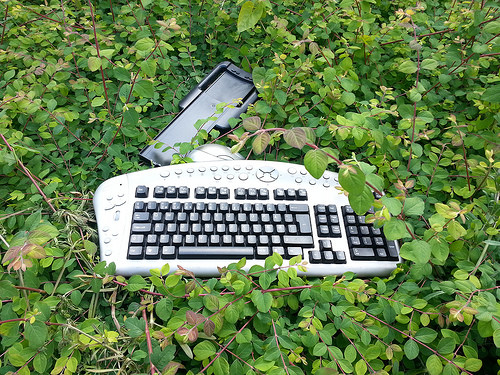<image>
Can you confirm if the keyboard is behind the plants? No. The keyboard is not behind the plants. From this viewpoint, the keyboard appears to be positioned elsewhere in the scene. Is there a keyboard on the tree? Yes. Looking at the image, I can see the keyboard is positioned on top of the tree, with the tree providing support. 